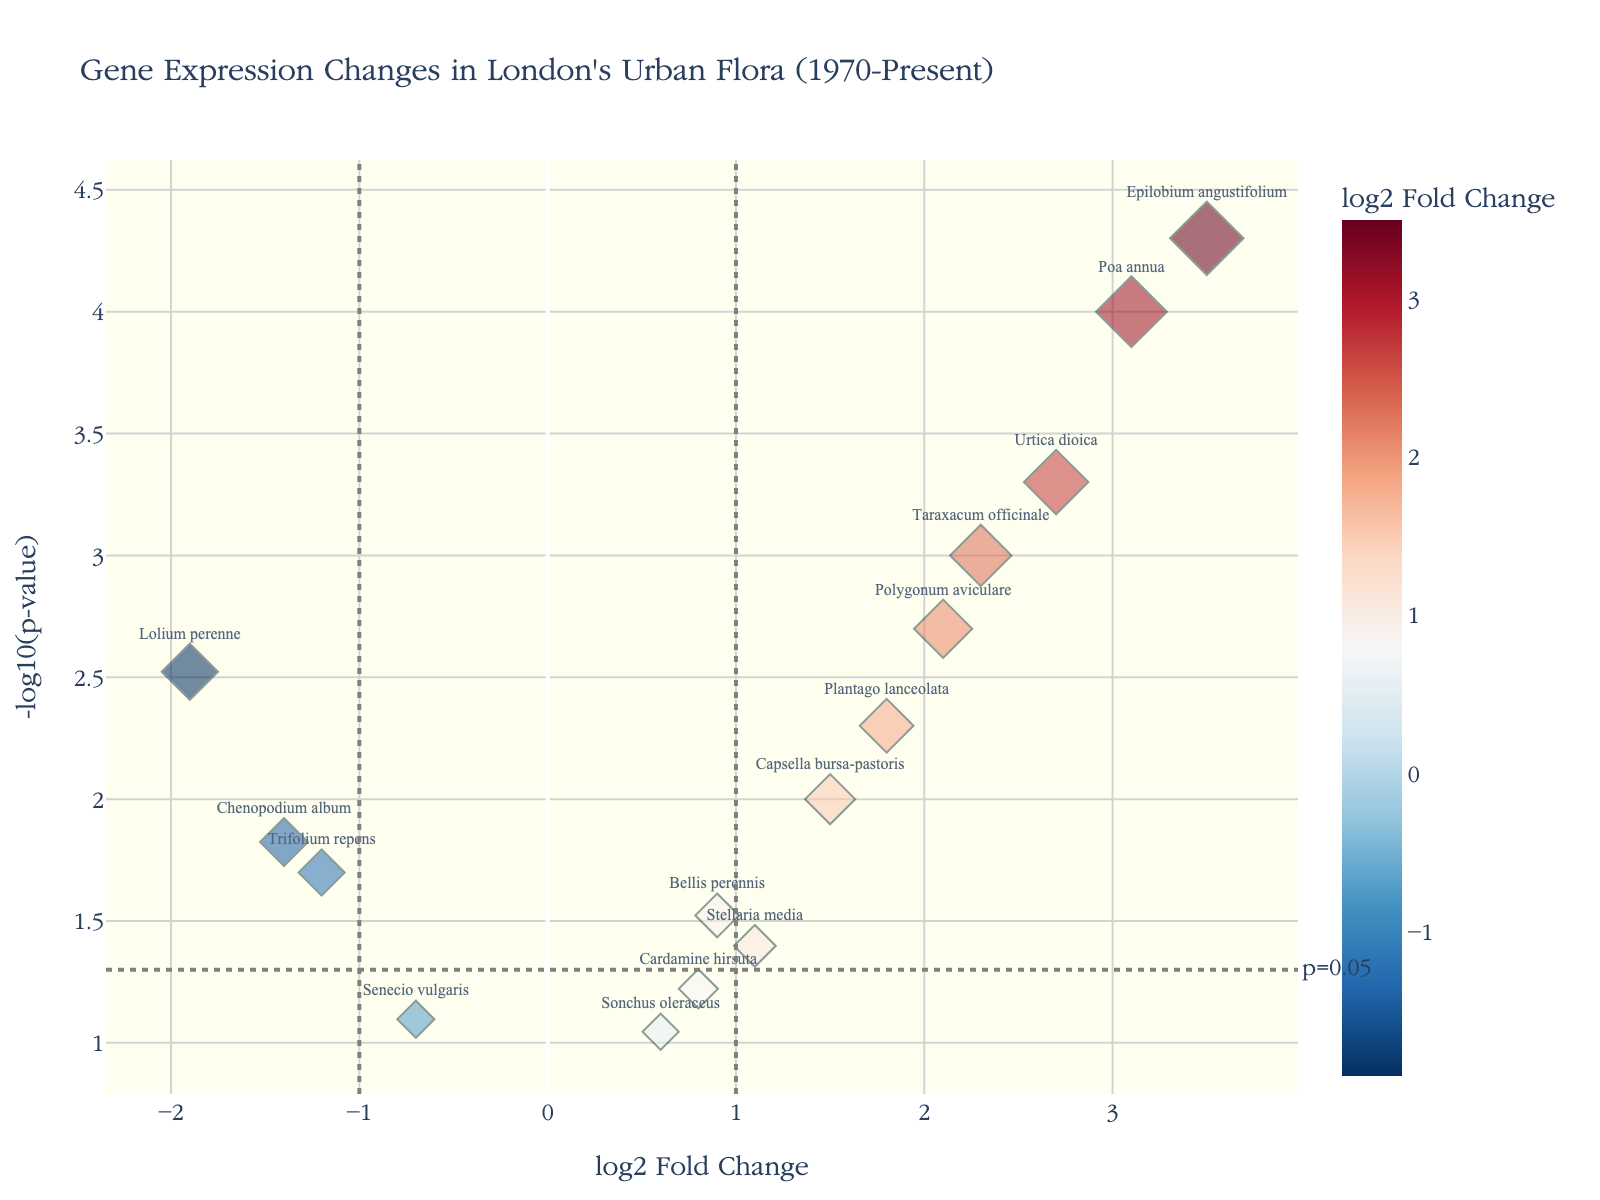How many plant species show a significant change in gene expression? Data points above the horizontal line at -log10(p-value) = 1.3 are considered significant. From the figure, there are 8 plant species above this threshold.
Answer: 8 Which species has the highest log2 fold change? By looking at the x-axis for the highest log2 fold change value, the species "Epilobium angustifolium" has the highest value of 3.5.
Answer: Epilobium angustifolium What is the threshold of significance for p-values as shown in the plot? The plot has a horizontal line at y = 1.3 which corresponds to -log10(0.05), indicating the p-value threshold for significance.
Answer: 0.05 Which species has the lowest (most negative) log2 fold change that is statistically significant? The species "Lolium perenne" has the lowest log2 fold change of -1.9 and is above the p-value threshold line, making it statistically significant.
Answer: Lolium perenne How many species have a log2 fold change greater than 1? Data points to the right of the vertical line at x = 1 indicate species with log2 fold change greater than 1. There are 6 such species: "Taraxacum officinale," "Plantago lanceolata," "Poa annua," "Urtica dioica," "Polygonum aviculare," and "Epilobium angustifolium."
Answer: 6 Which species had the smallest p-value? The species with the highest y-value (largest -log10(p-value)) represents the smallest p-value. "Epilobium angustifolium" has the highest y-value of 4.301.
Answer: Epilobium angustifolium Compare "Taraxacum officinale" and "Trifolium repens": which one has a higher log2 fold change and which one is statistically significant? "Taraxacum officinale" has a log2 fold change of 2.3, which is higher than "Trifolium repens" at -1.2. Regarding significance, "Taraxacum officinale" is above the p-value threshold line while "Trifolium repens" is also above it but less significantly so.
Answer: Taraxacum officinale is higher, both are significant What is the range of log2 fold changes among all species? The lowest log2 fold change is -1.9 by "Lolium perenne" and the highest is 3.5 by "Epilobium angustifolium," making the range 3.5 - (-1.9) = 5.4.
Answer: 5.4 Which species are significantly upregulated (log2 fold change > 1 and significant p-value)? Species with log2 fold change > 1 and -log10(p-value) > 1.3 are "Taraxacum officinale," "Plantago lanceolata," "Poa annua," "Urtica dioica," "Polygonum aviculare," and "Epilobium angustifolium."
Answer: 6 species 